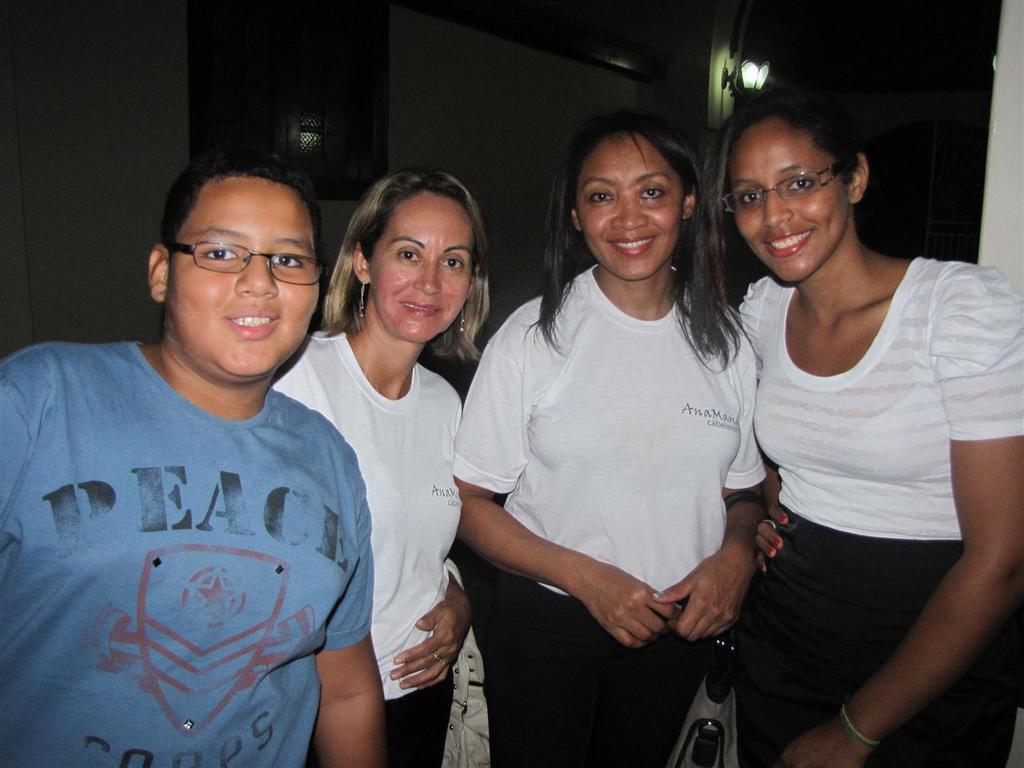Can you describe this image briefly? In this image we can see the people standing. In the background, we can see a wall with window and light. 